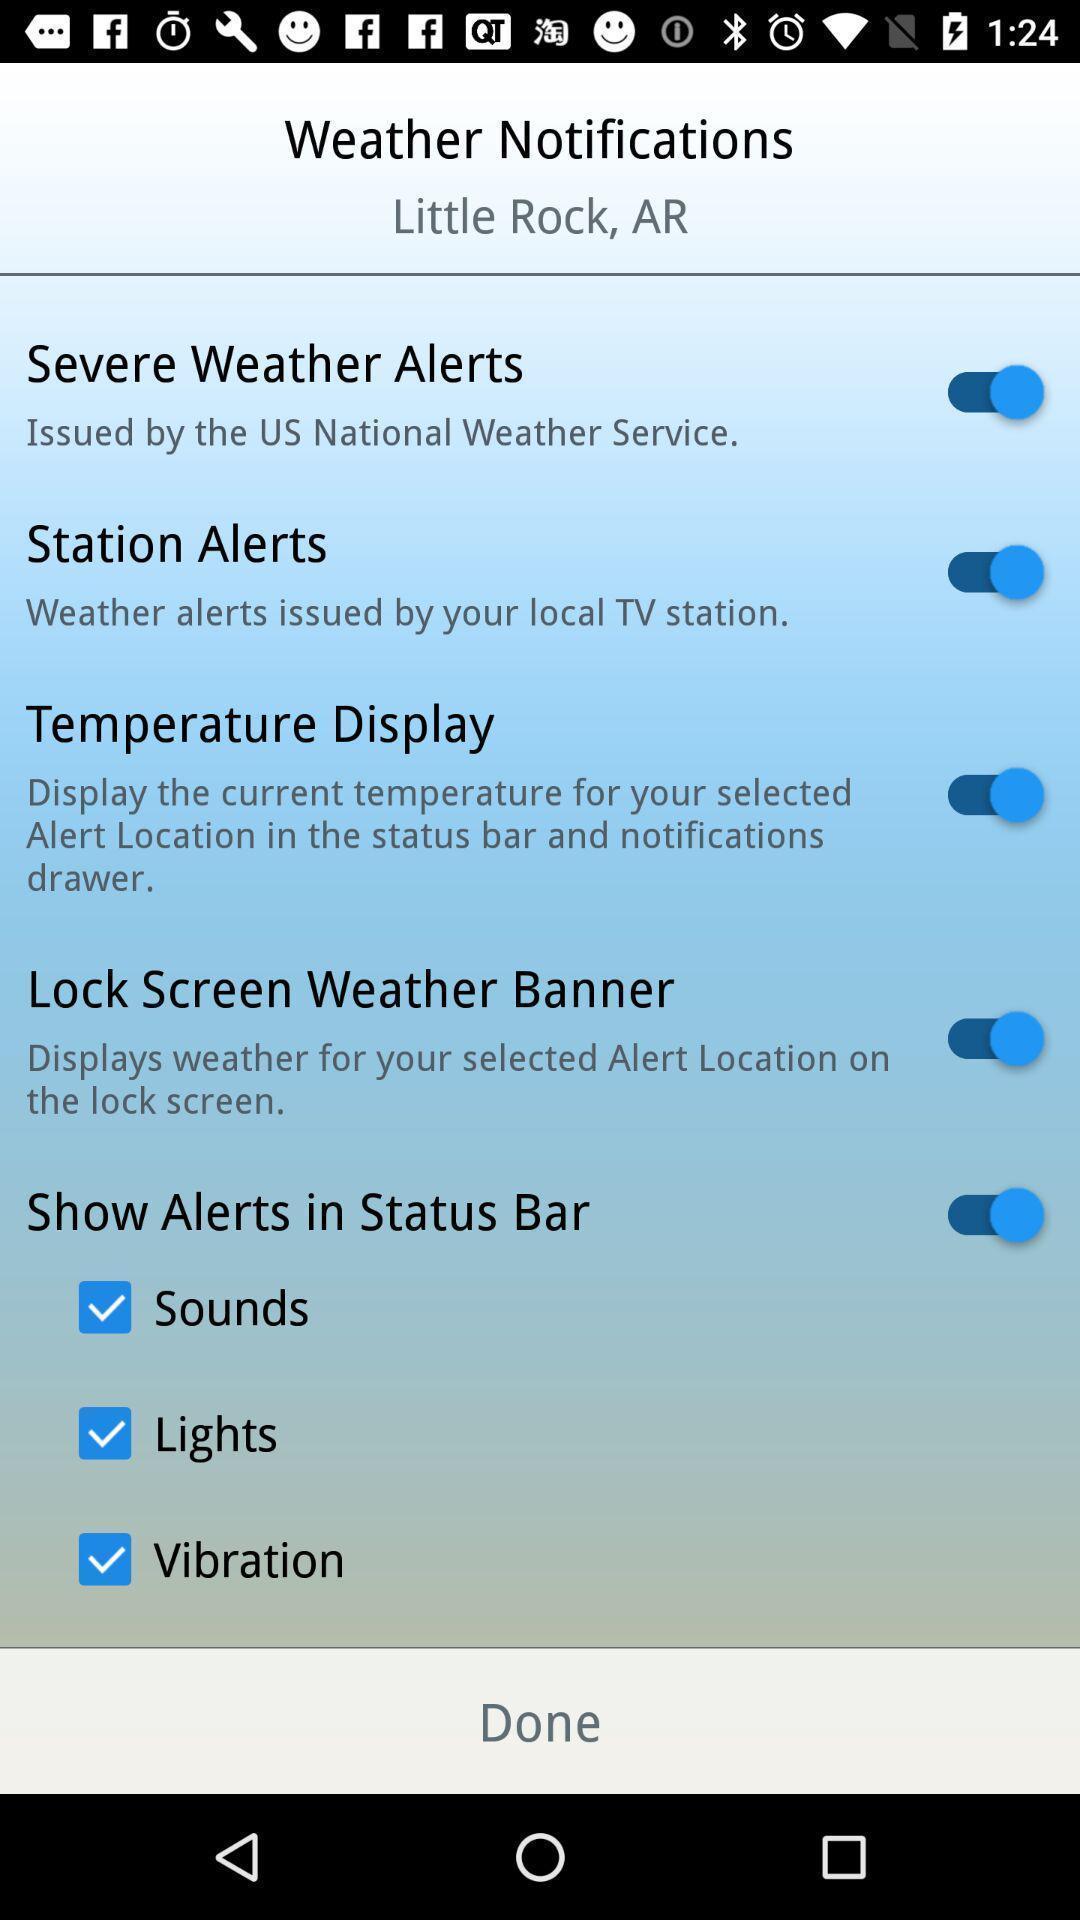Describe the key features of this screenshot. Weather notifications in a weather app. 